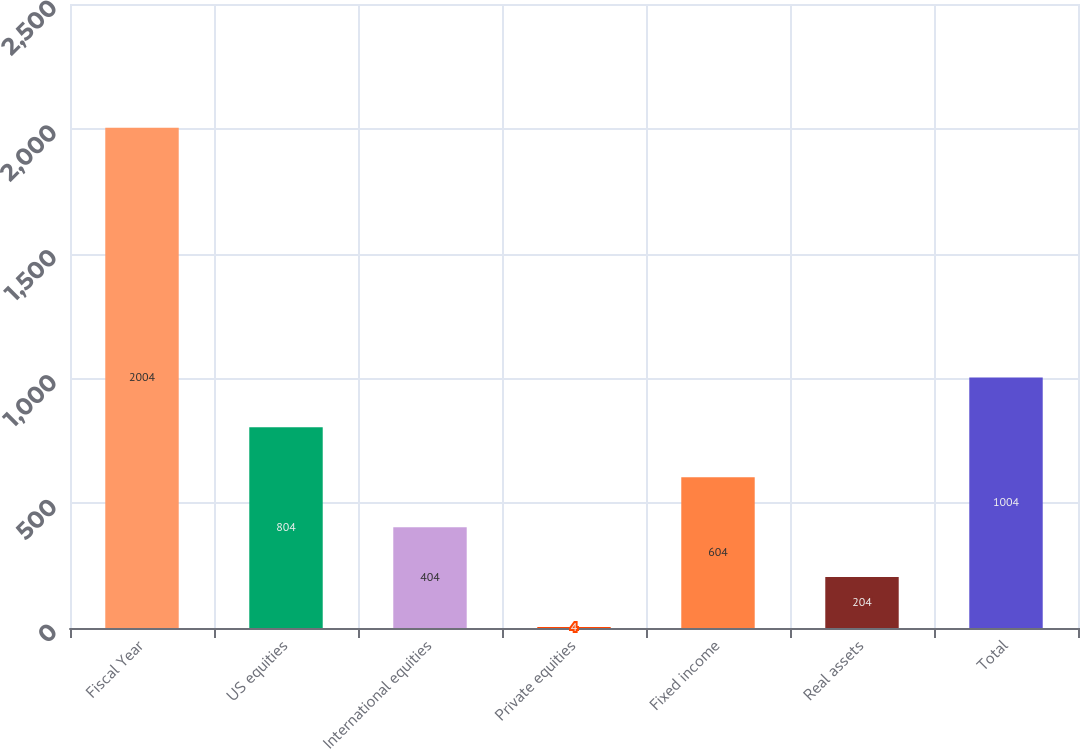<chart> <loc_0><loc_0><loc_500><loc_500><bar_chart><fcel>Fiscal Year<fcel>US equities<fcel>International equities<fcel>Private equities<fcel>Fixed income<fcel>Real assets<fcel>Total<nl><fcel>2004<fcel>804<fcel>404<fcel>4<fcel>604<fcel>204<fcel>1004<nl></chart> 